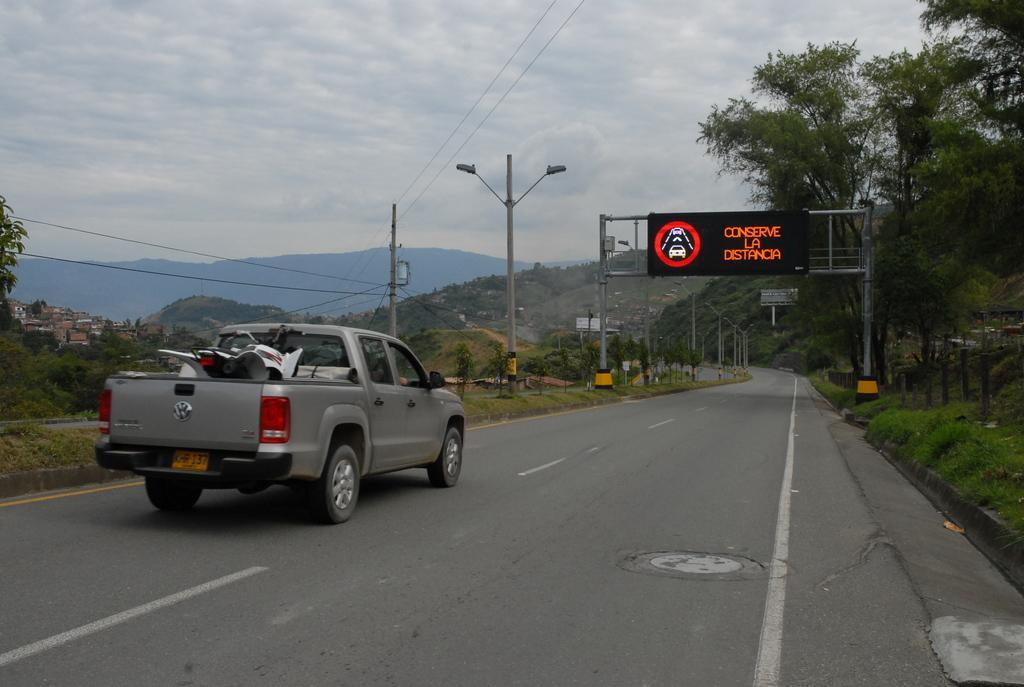Could you give a brief overview of what you see in this image? In this image there is a road in the middle. On the road there is a van. In the van there is a motorbike. On the right side there is a boarding in the middle of the road. At the top there is sky. In the background there are hills. There are electric poles and light poles on the footpath. 